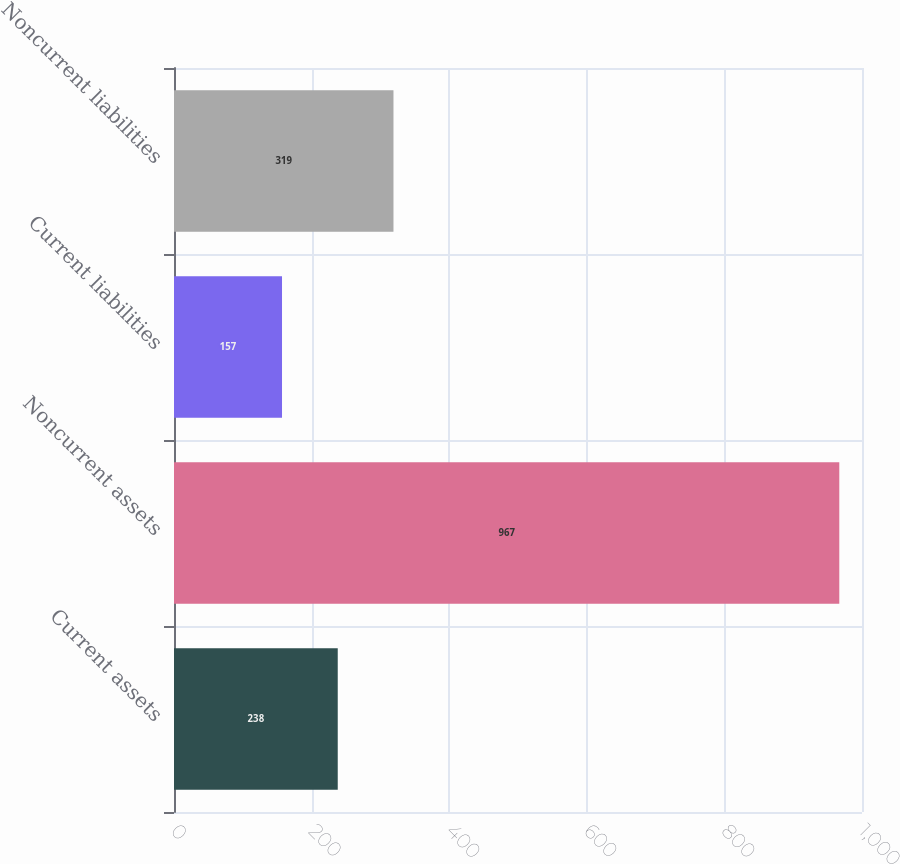Convert chart. <chart><loc_0><loc_0><loc_500><loc_500><bar_chart><fcel>Current assets<fcel>Noncurrent assets<fcel>Current liabilities<fcel>Noncurrent liabilities<nl><fcel>238<fcel>967<fcel>157<fcel>319<nl></chart> 